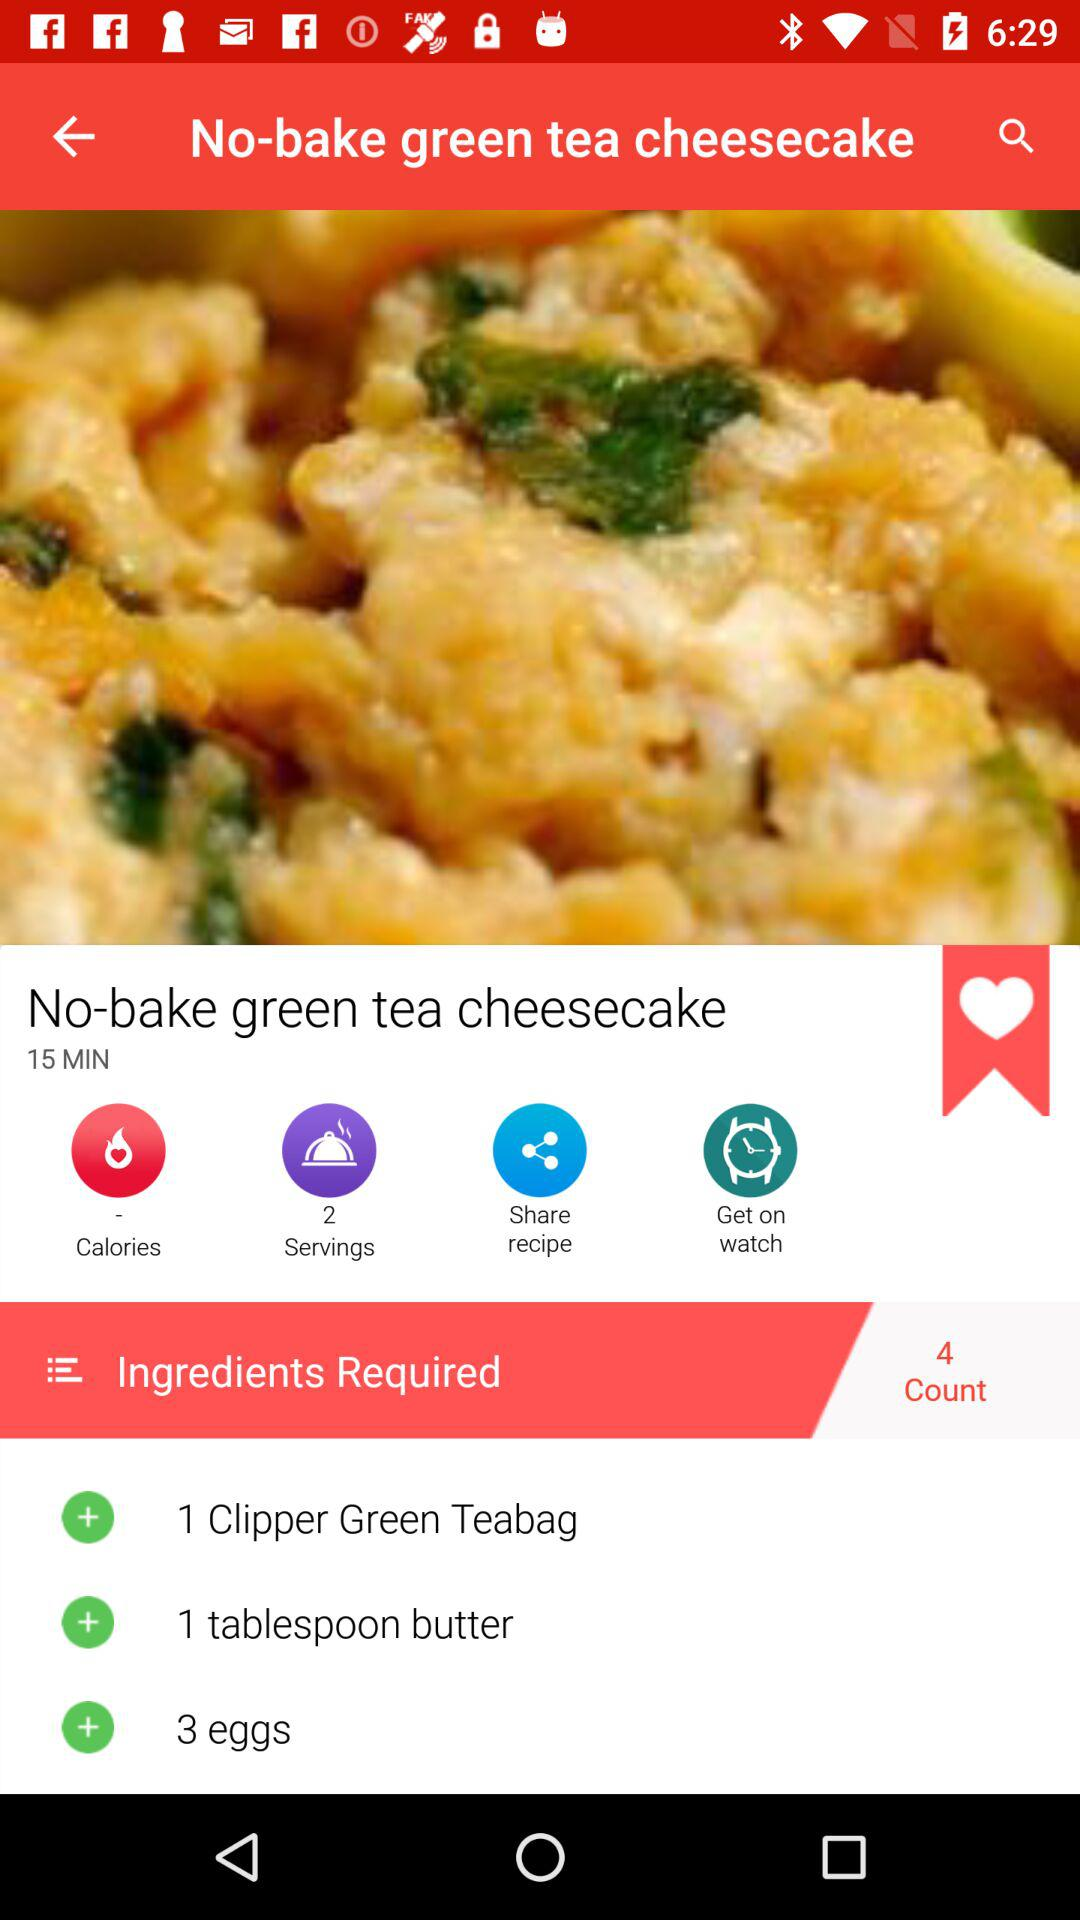Which ingredients are required for making "No-bake green tea cheesecake"? The ingredients required for making "No-bake green tea cheesecake" are 1 clipper bag of green tea, 1 tablespoon of butter and 3 eggs. 